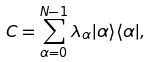Convert formula to latex. <formula><loc_0><loc_0><loc_500><loc_500>C = \sum ^ { N - 1 } _ { \alpha = 0 } \lambda _ { \alpha } | \alpha \rangle \langle \alpha | ,</formula> 